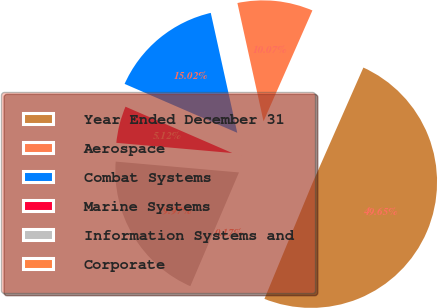Convert chart to OTSL. <chart><loc_0><loc_0><loc_500><loc_500><pie_chart><fcel>Year Ended December 31<fcel>Aerospace<fcel>Combat Systems<fcel>Marine Systems<fcel>Information Systems and<fcel>Corporate<nl><fcel>49.65%<fcel>10.07%<fcel>15.02%<fcel>5.12%<fcel>19.97%<fcel>0.17%<nl></chart> 